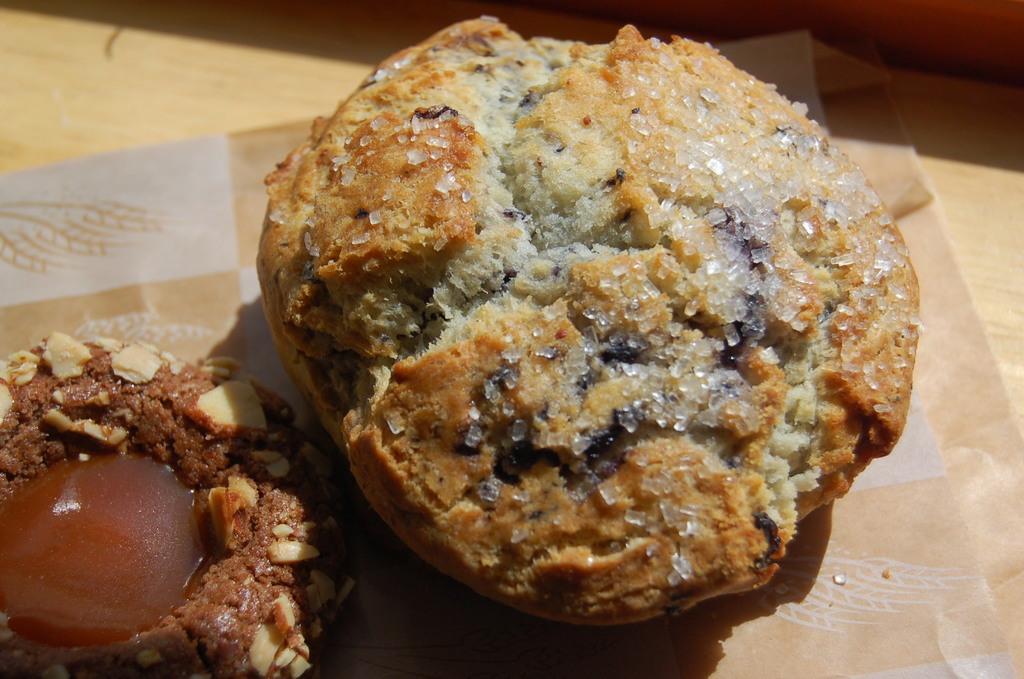Can you describe this image briefly? In this image I can see two cookies on a paper. In the background, I can see a wooden surface. 